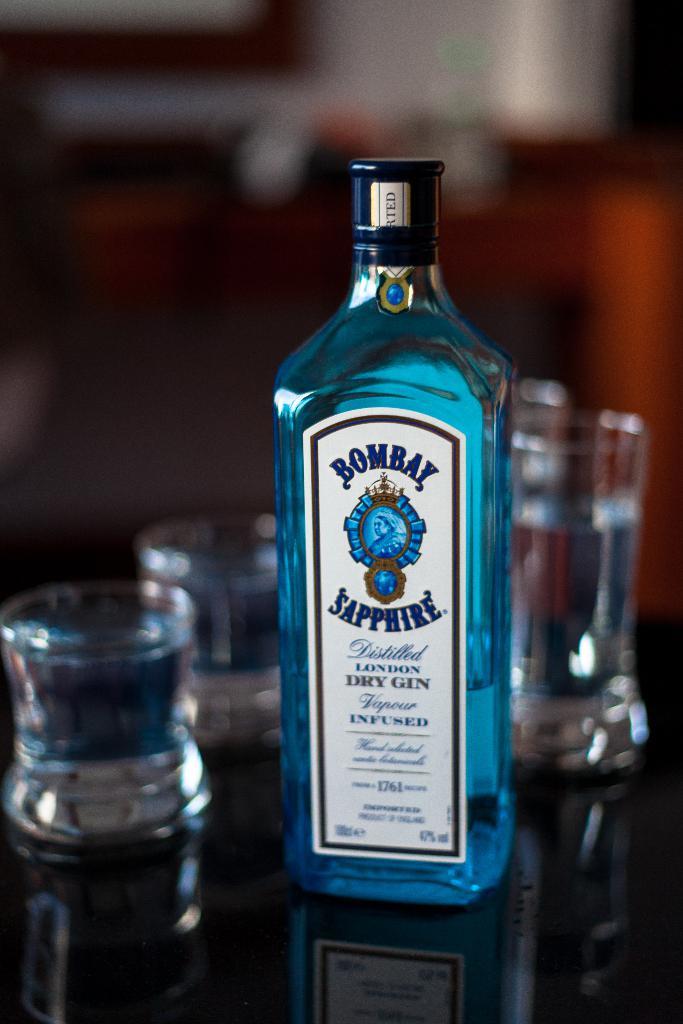What is the brand name that is written on the bottle on the top?
Give a very brief answer. Bombay. Where is the gin from?
Provide a short and direct response. Bombay. 